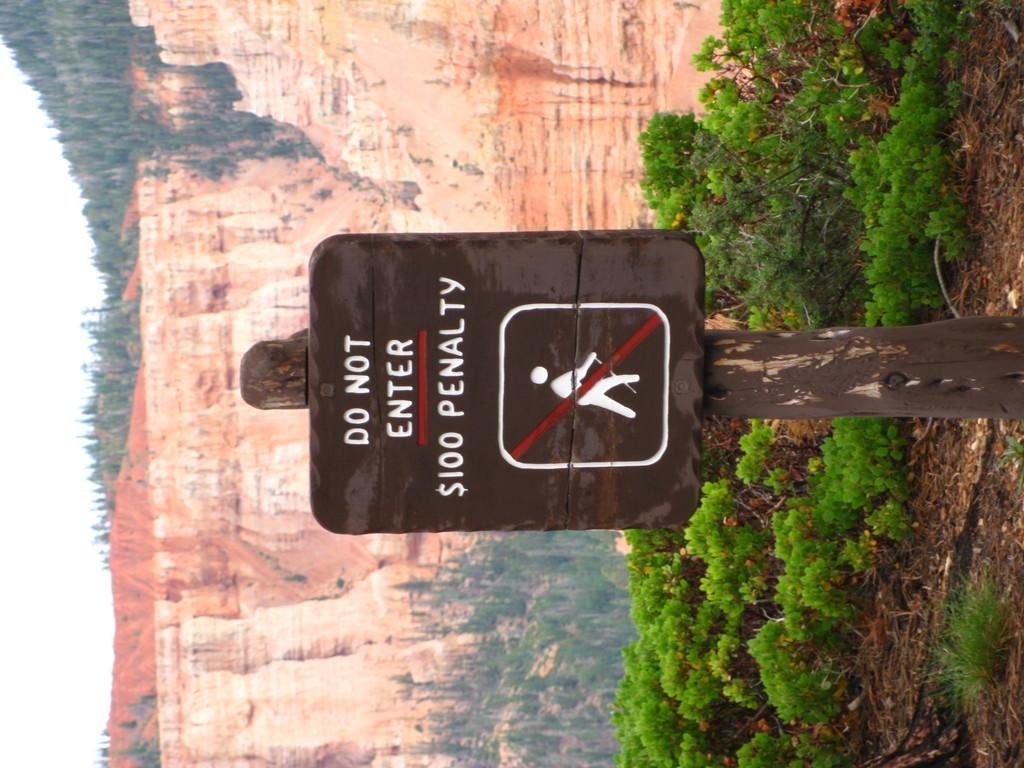What is attached to the pole in the image? There is a sign board attached to a pole in the image. What type of vegetation can be seen in the image? There are plants and trees in the image. What geographical feature is visible in the image? There are mountains in the image. What can be seen in the background of the image? The sky is visible in the background of the image. What type of hope does the mother have for her child in the image? There is no mother or child present in the image, so it is not possible to answer that question. 